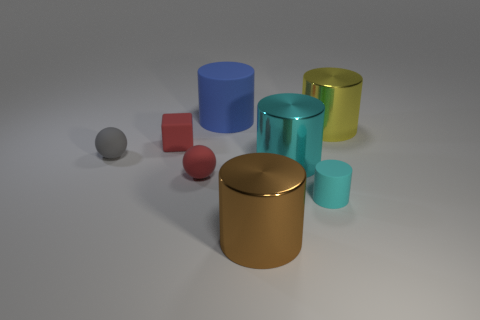Subtract all small cyan cylinders. How many cylinders are left? 4 Subtract 1 cylinders. How many cylinders are left? 4 Subtract all green spheres. How many cyan cylinders are left? 2 Subtract all brown cylinders. How many cylinders are left? 4 Add 2 tiny brown blocks. How many objects exist? 10 Subtract all yellow cylinders. Subtract all yellow cubes. How many cylinders are left? 4 Subtract all blocks. How many objects are left? 7 Subtract all purple rubber objects. Subtract all yellow things. How many objects are left? 7 Add 1 tiny cyan things. How many tiny cyan things are left? 2 Add 1 big blue matte balls. How many big blue matte balls exist? 1 